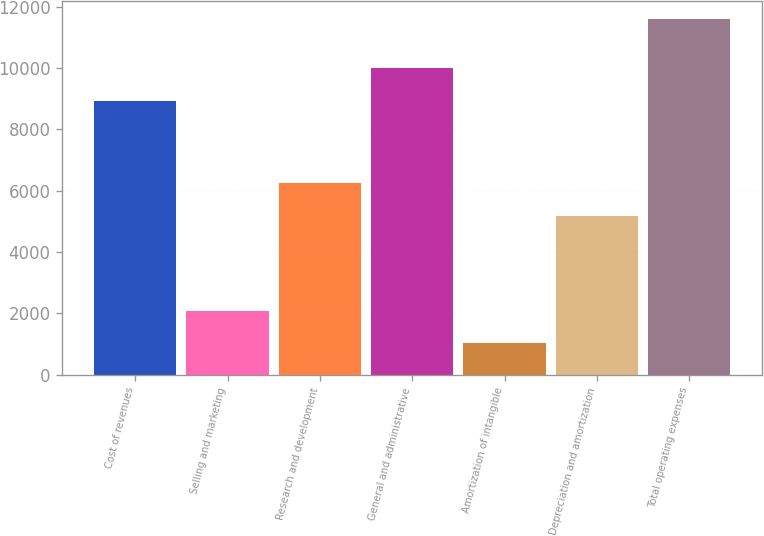<chart> <loc_0><loc_0><loc_500><loc_500><bar_chart><fcel>Cost of revenues<fcel>Selling and marketing<fcel>Research and development<fcel>General and administrative<fcel>Amortization of intangible<fcel>Depreciation and amortization<fcel>Total operating expenses<nl><fcel>8928<fcel>2089.8<fcel>6234.8<fcel>9984.8<fcel>1033<fcel>5178<fcel>11601<nl></chart> 